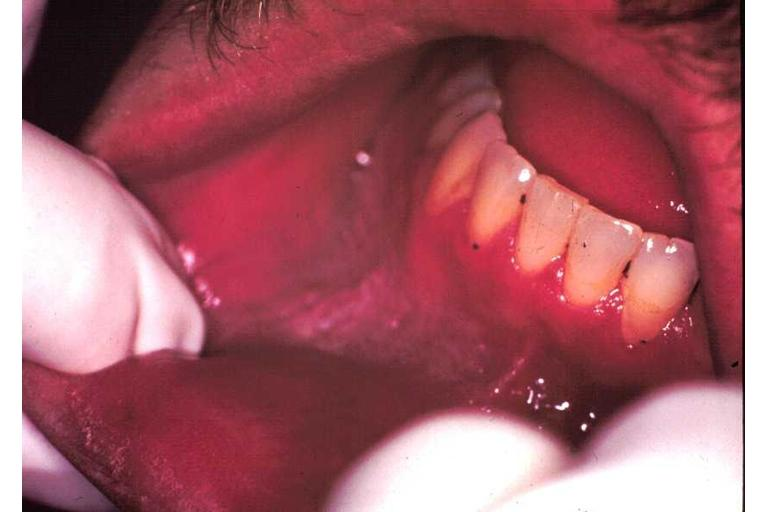s alpha smooth muscle actin immunohistochemical present?
Answer the question using a single word or phrase. No 